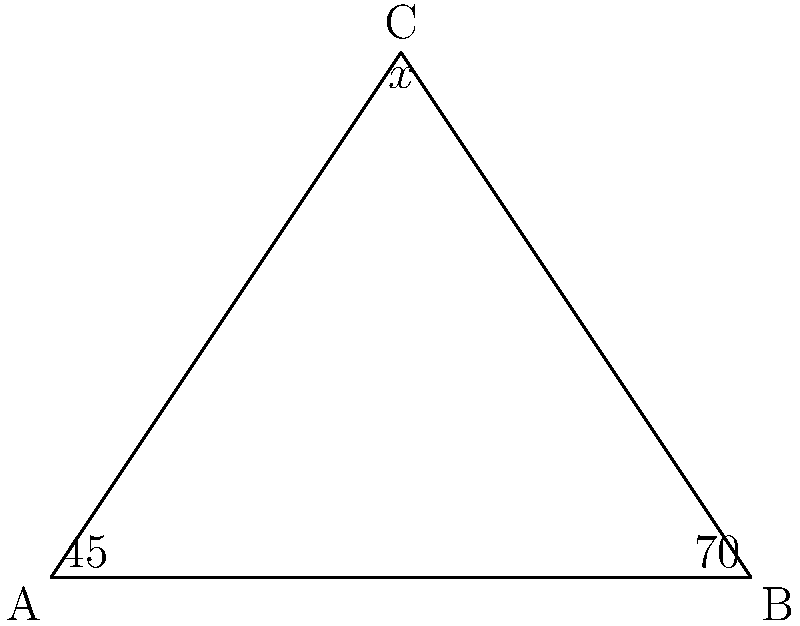In the context of developing an interactive geometry game for enhancing spatial reasoning skills, consider the triangle ABC shown. Given that angle A is $45°$ and angle B is $70°$, determine the value of angle C (represented by $x°$). How might this type of problem contribute to students' understanding of geometric principles in an interactive learning environment? To solve this problem and understand its educational value, let's follow these steps:

1) Recall the fundamental principle: The sum of angles in a triangle is always $180°$.

2) Let's express this mathematically:
   $\angle A + \angle B + \angle C = 180°$

3) We know two of the angles:
   $\angle A = 45°$
   $\angle B = 70°$

4) Let's substitute these values into our equation:
   $45° + 70° + x° = 180°$

5) Simplify:
   $115° + x° = 180°$

6) Solve for $x$:
   $x° = 180° - 115°$
   $x° = 65°$

This type of problem is valuable in an interactive learning environment because:

a) It reinforces the concept of angle sum in triangles.
b) It practices algebraic problem-solving skills in a geometric context.
c) In an interactive game, students could manipulate the triangle and observe how changing one angle affects the others, promoting spatial reasoning.
d) It demonstrates the interconnectedness of geometric principles, encouraging holistic understanding.
e) The visual representation aids in conceptual understanding, which is particularly beneficial for visual learners.
Answer: $65°$ 